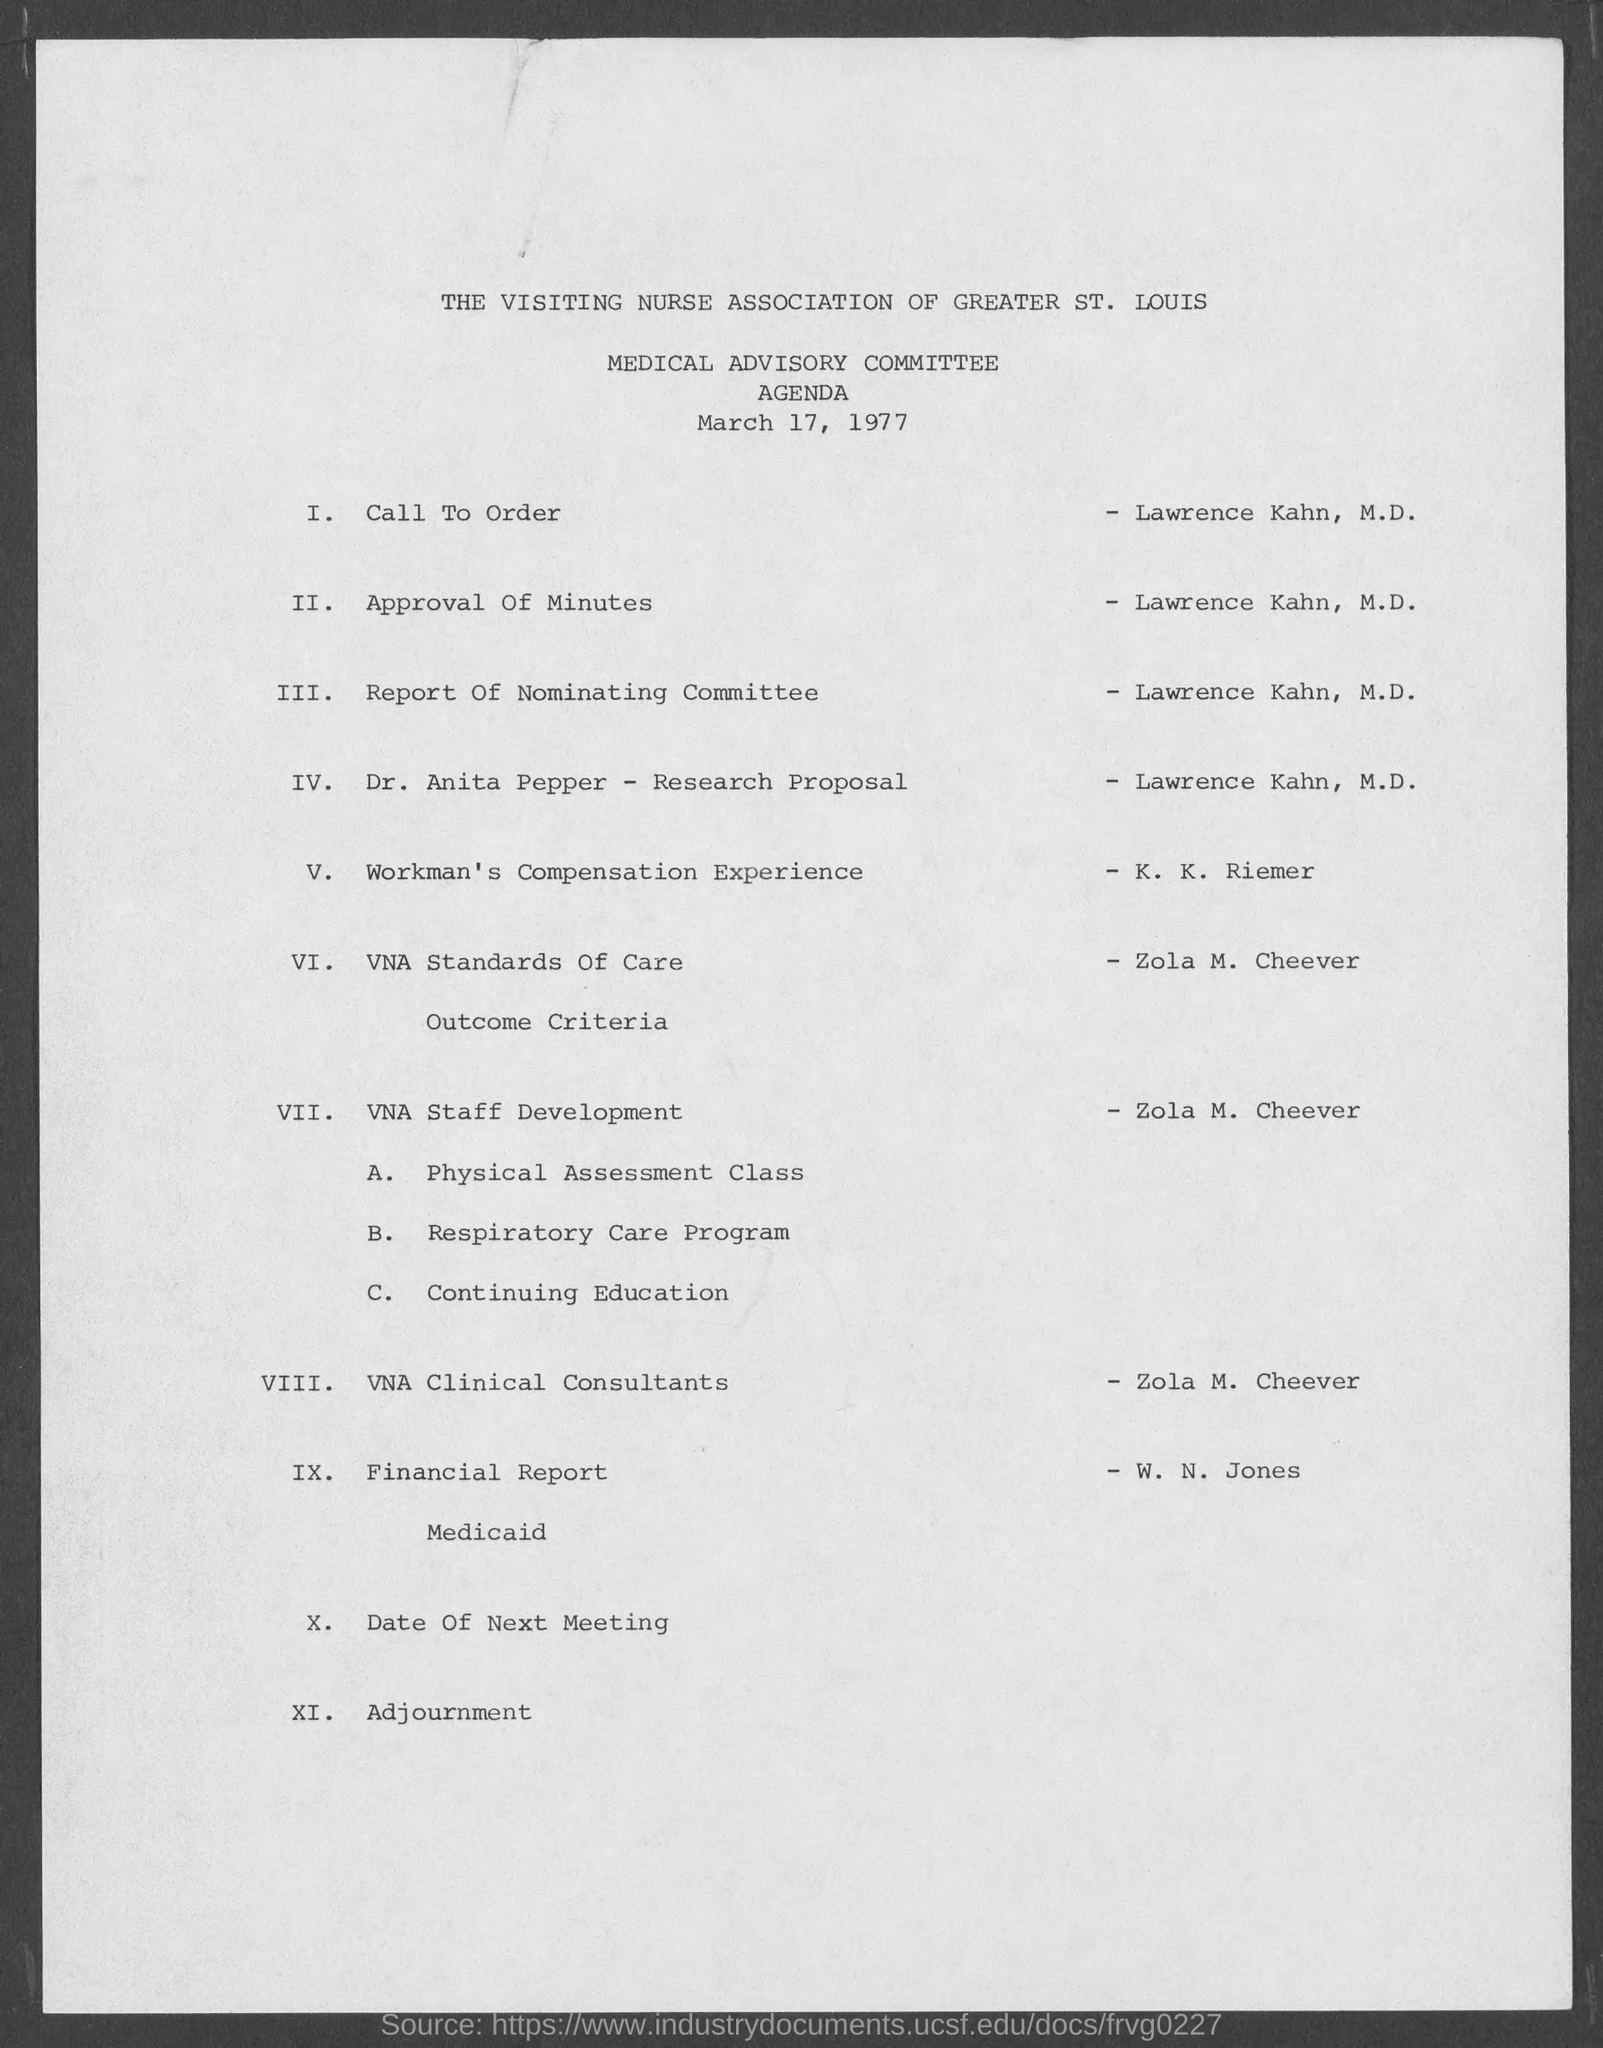Which association is mentioned?
Provide a succinct answer. The visiting nurse association of greater st. louis. Which committee is mentioned?
Provide a succinct answer. Medical advisory committee. When is the document dated?
Make the answer very short. March 17, 1977. Who is doing the Call To Order?
Provide a succinct answer. Lawrence kahn. What is K. K. Riemer's topic?
Your response must be concise. Workman's Compensation Experience. Who is doing the Financial Report?
Offer a very short reply. W. N. Jones. 